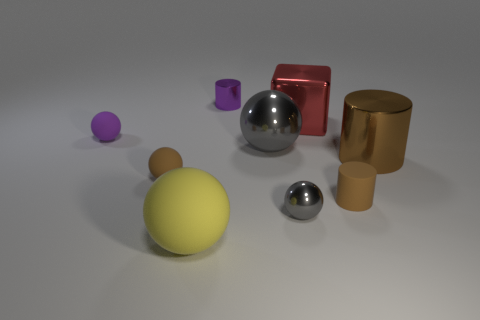Subtract all brown matte spheres. How many spheres are left? 4 Subtract all green spheres. Subtract all cyan cubes. How many spheres are left? 5 Add 1 cyan shiny cylinders. How many objects exist? 10 Subtract all blocks. How many objects are left? 8 Add 7 large metallic cylinders. How many large metallic cylinders are left? 8 Add 6 big gray metallic blocks. How many big gray metallic blocks exist? 6 Subtract 0 yellow cylinders. How many objects are left? 9 Subtract all big metal cylinders. Subtract all large things. How many objects are left? 4 